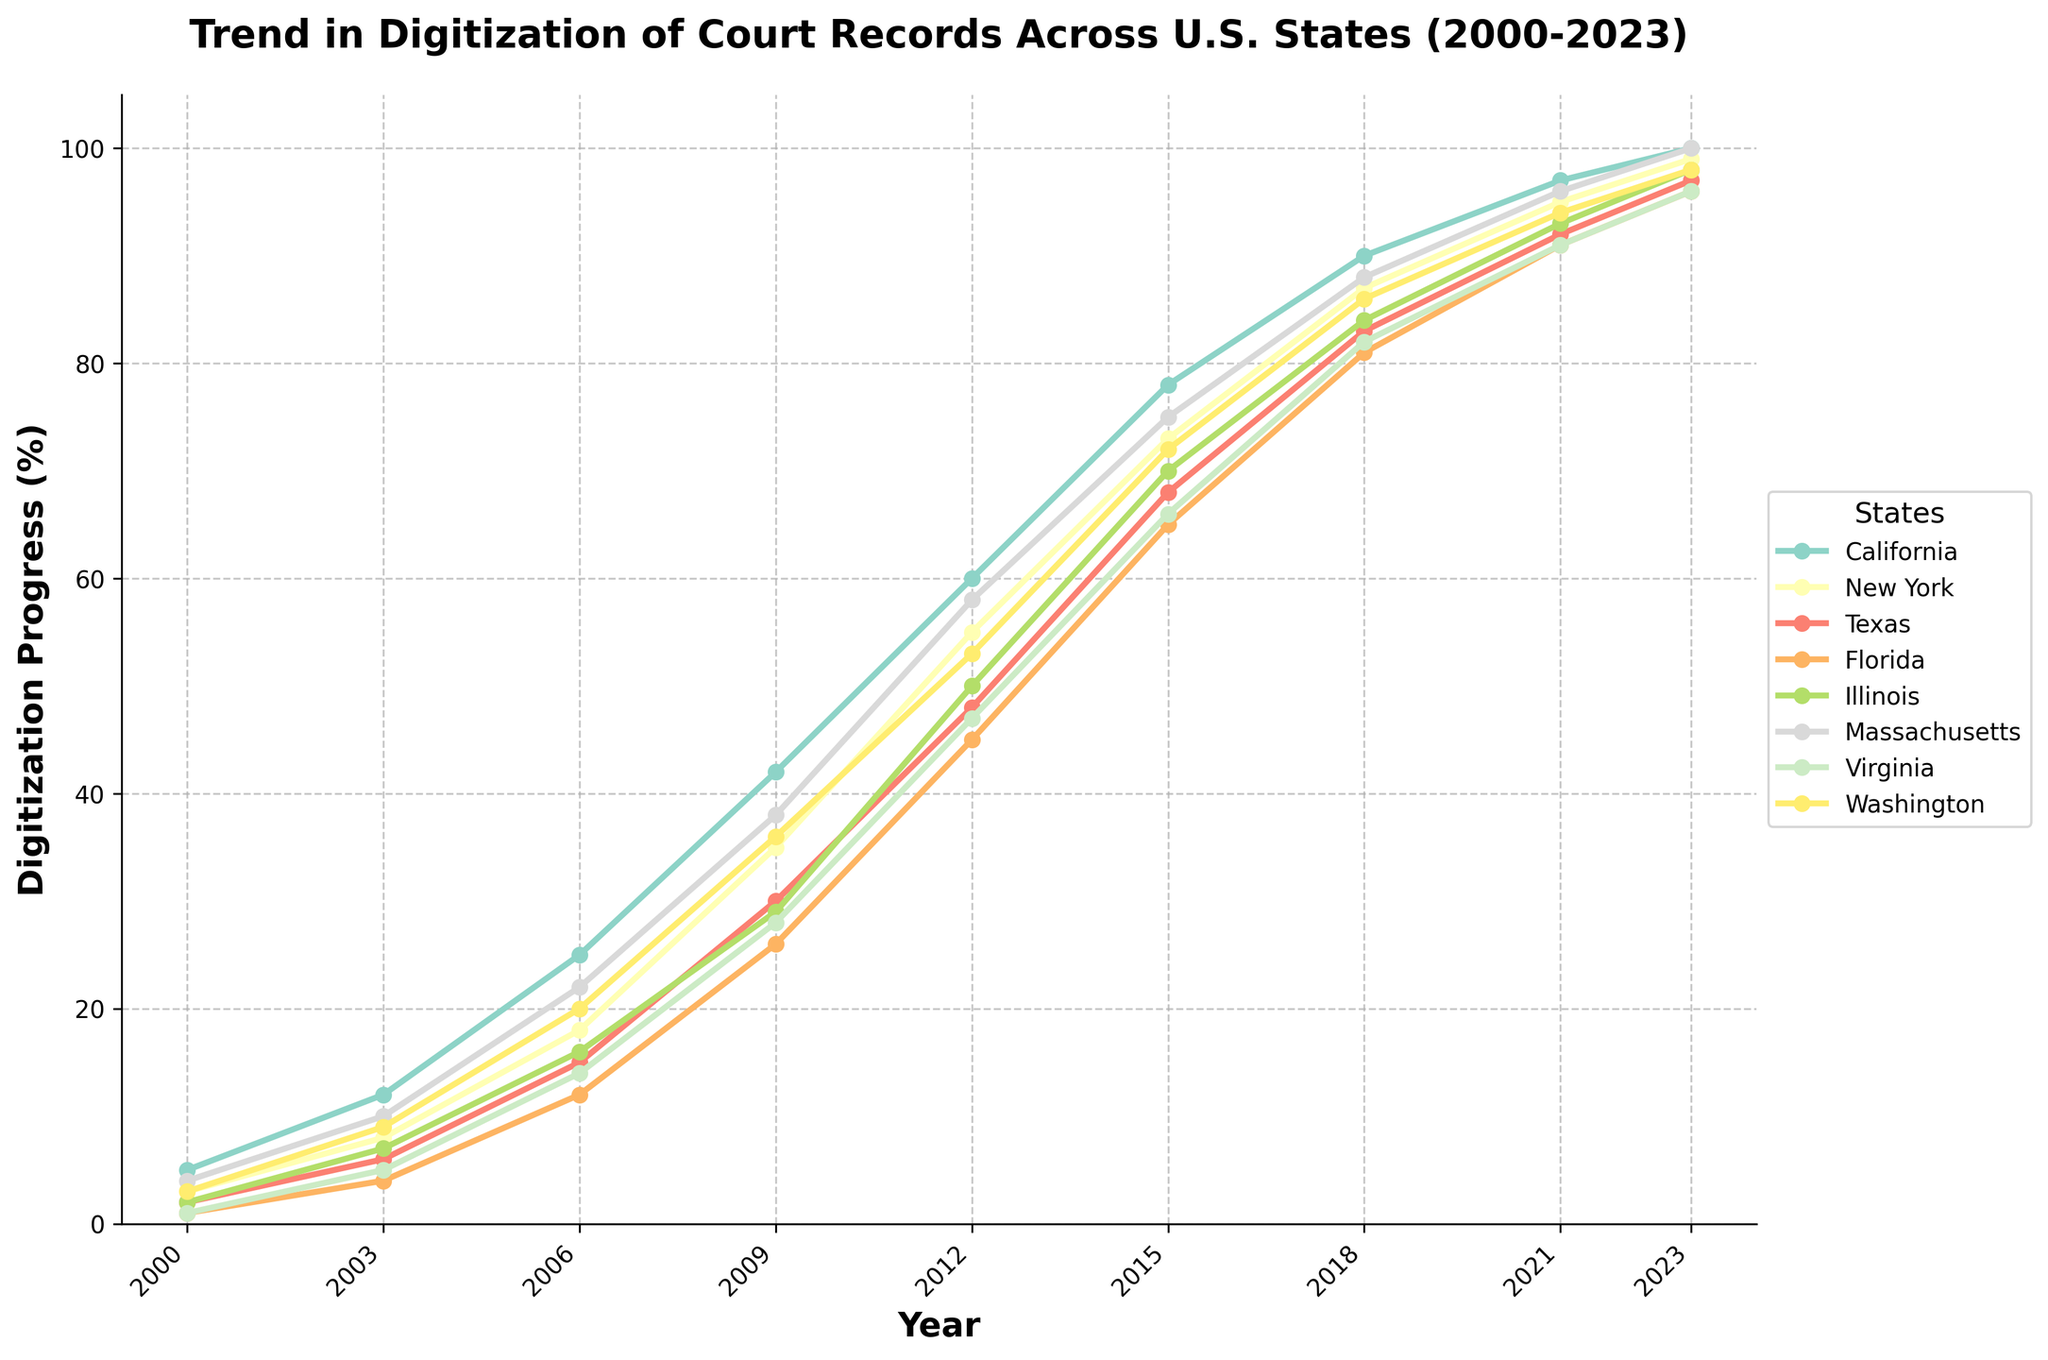Which state had the highest digitization percentage in 2023? To determine which state had the highest digitization percentage in 2023, check the values on the y-axis for different states. California and Massachusetts both have 100% in 2023.
Answer: California, Massachusetts Which state showed the largest increase in digitization from 2000 to 2006? To find the largest increase between 2000 and 2006, subtract the 2000 value from the 2006 value for each state. California increased by 20, New York by 15, Texas by 13, Florida by 11, Illinois by 14, Massachusetts by 18, Virginia by 13, and Washington by 17. California increased the most (25 - 5).
Answer: California What was the average digitization percentage across all states in 2012? To find the average digitization percentage in 2012, add the percentages of all states and divide by the number of states: (60 + 55 + 48 + 45 + 50 + 58 + 47 + 53) / 8 = 52.
Answer: 52 Which two states had the closest digitization percentages in 2021? Compare the digitization percentages of the states in 2021. Virginia (91) and Florida (91) have the same percentage and are closest to each other.
Answer: Virginia, Florida How many states had surpassed the 90% digitization mark by 2018? Count the states which had digitization percentages above 90 in 2018. California (90), New York (87), Texas (83), Florida (81), Illinois (84), Massachusetts (88), Virginia (82), and Washington (86)—there are no states; all are below 90.
Answer: 0 Between which years did New York see the fastest growth in digitization? To find the period of fastest growth for New York, look at the slopes of the line segments between the years. New York's digitization increased the most rapidly between 2000 (3) and 2003 (8). Calculating the yearly growth, (8-3)/3 = 1.67 per year. This interval shows the fastest proportional growth comparing to other stretch lengths.
Answer: 2000-2003 Is Massachusetts' digitization percentage higher than Virginia's in 2015? Compare the digitization percentages of Massachusetts (75) and Virginia (66) in 2015. Yes, Massachusetts' digitization percentage is higher.
Answer: Yes Looking at the trend, what can you infer about the digitization growth in California between 2009 and 2023? For California, observe the line's slope between 2009 and 2023. The growth becomes steadier and increases at a somewhat decreasing rate (even though values hit 100). Early values sharply increase from 42 to 60 (in 2012), while later values (78 to 90 to 97 to 100) show a smoothing curve.
Answer: Steady growth 